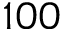<formula> <loc_0><loc_0><loc_500><loc_500>1 0 0</formula> 